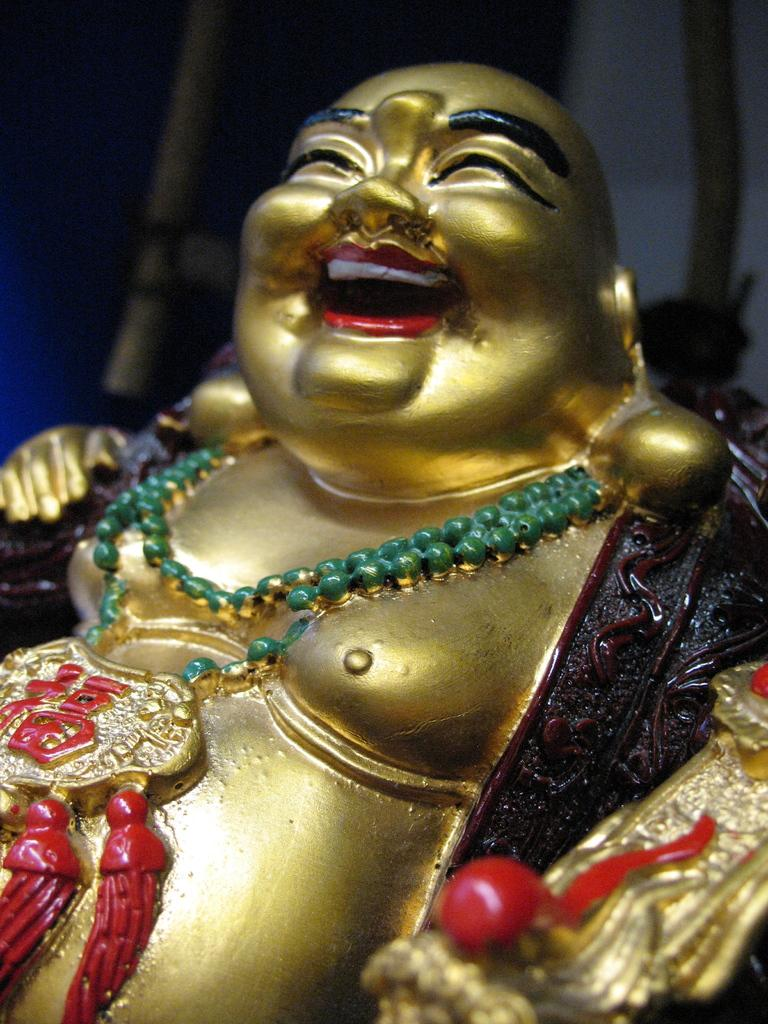What is the main subject of the image? There is a statue in the image. Can you describe the background of the image? The background of the image is blurred. Despite the blurred background, are there any objects visible? Yes, there are objects visible in the blurred background. How does the visitor react to the surprise in the image? There is no visitor or surprise present in the image; it only features a statue and a blurred background. 